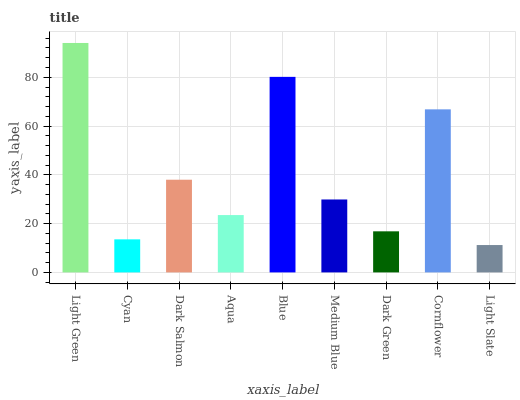Is Light Slate the minimum?
Answer yes or no. Yes. Is Light Green the maximum?
Answer yes or no. Yes. Is Cyan the minimum?
Answer yes or no. No. Is Cyan the maximum?
Answer yes or no. No. Is Light Green greater than Cyan?
Answer yes or no. Yes. Is Cyan less than Light Green?
Answer yes or no. Yes. Is Cyan greater than Light Green?
Answer yes or no. No. Is Light Green less than Cyan?
Answer yes or no. No. Is Medium Blue the high median?
Answer yes or no. Yes. Is Medium Blue the low median?
Answer yes or no. Yes. Is Cyan the high median?
Answer yes or no. No. Is Light Slate the low median?
Answer yes or no. No. 